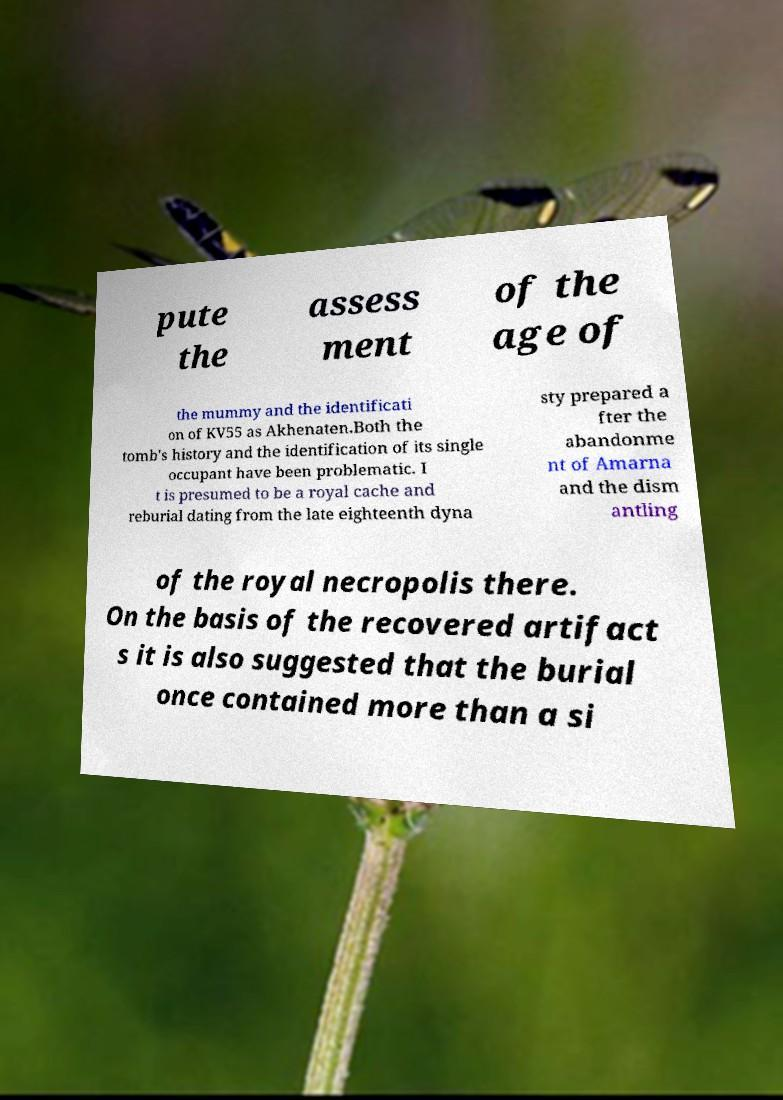Can you accurately transcribe the text from the provided image for me? pute the assess ment of the age of the mummy and the identificati on of KV55 as Akhenaten.Both the tomb's history and the identification of its single occupant have been problematic. I t is presumed to be a royal cache and reburial dating from the late eighteenth dyna sty prepared a fter the abandonme nt of Amarna and the dism antling of the royal necropolis there. On the basis of the recovered artifact s it is also suggested that the burial once contained more than a si 